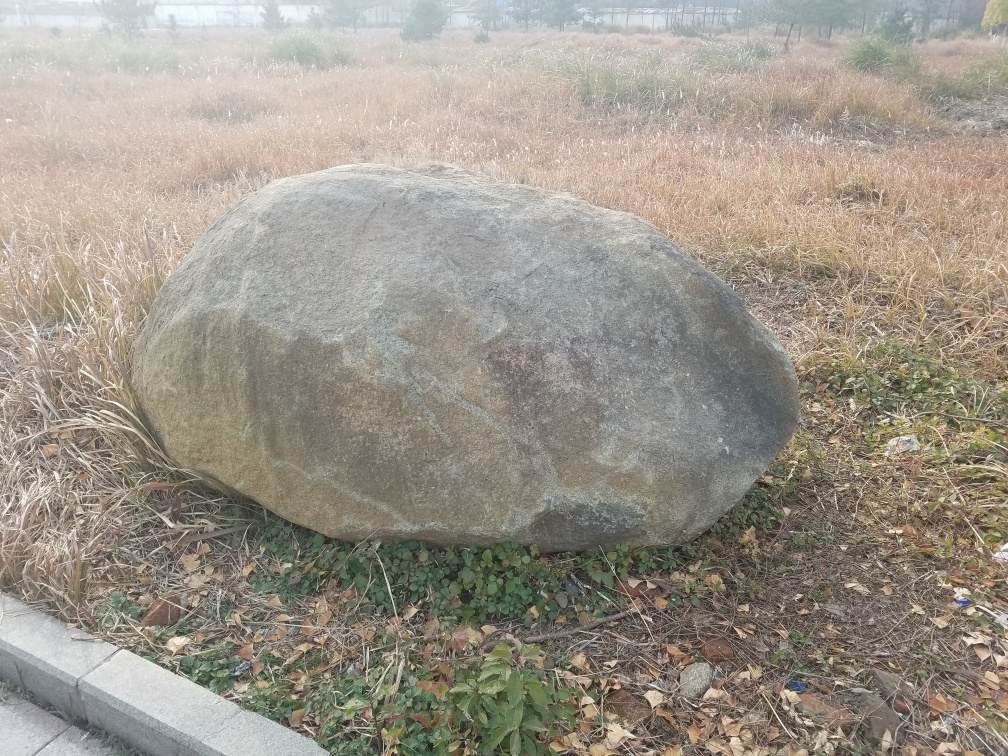Can you tell me more about the composition of this image? This image features a large boulder in the foreground, which appears to be the main subject. The boulder is set against a backdrop of dried, amber-hued grass. There are subtle hints of green, indicating some live vegetation. The overcast sky suggests it might be an early morning or a cloudy day, contributing to a somber tone. The angle of the shot seems casual, without much emphasis on symmetry or perspective. 